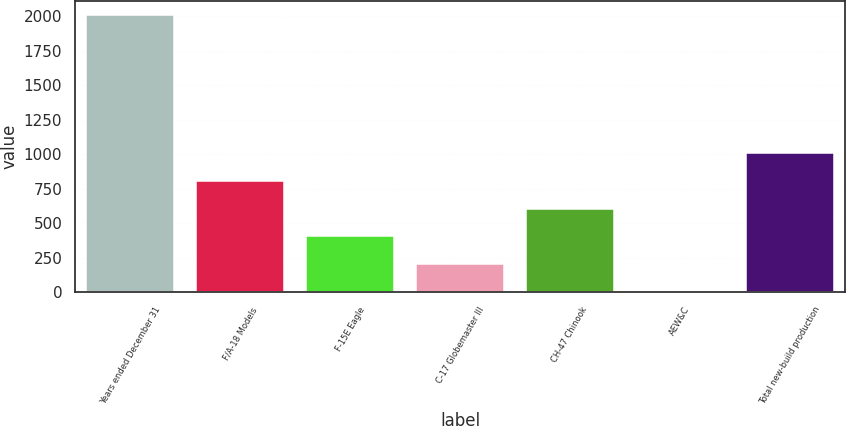<chart> <loc_0><loc_0><loc_500><loc_500><bar_chart><fcel>Years ended December 31<fcel>F/A-18 Models<fcel>F-15E Eagle<fcel>C-17 Globemaster III<fcel>CH-47 Chinook<fcel>AEW&C<fcel>Total new-build production<nl><fcel>2011<fcel>806.2<fcel>404.6<fcel>203.8<fcel>605.4<fcel>3<fcel>1007<nl></chart> 